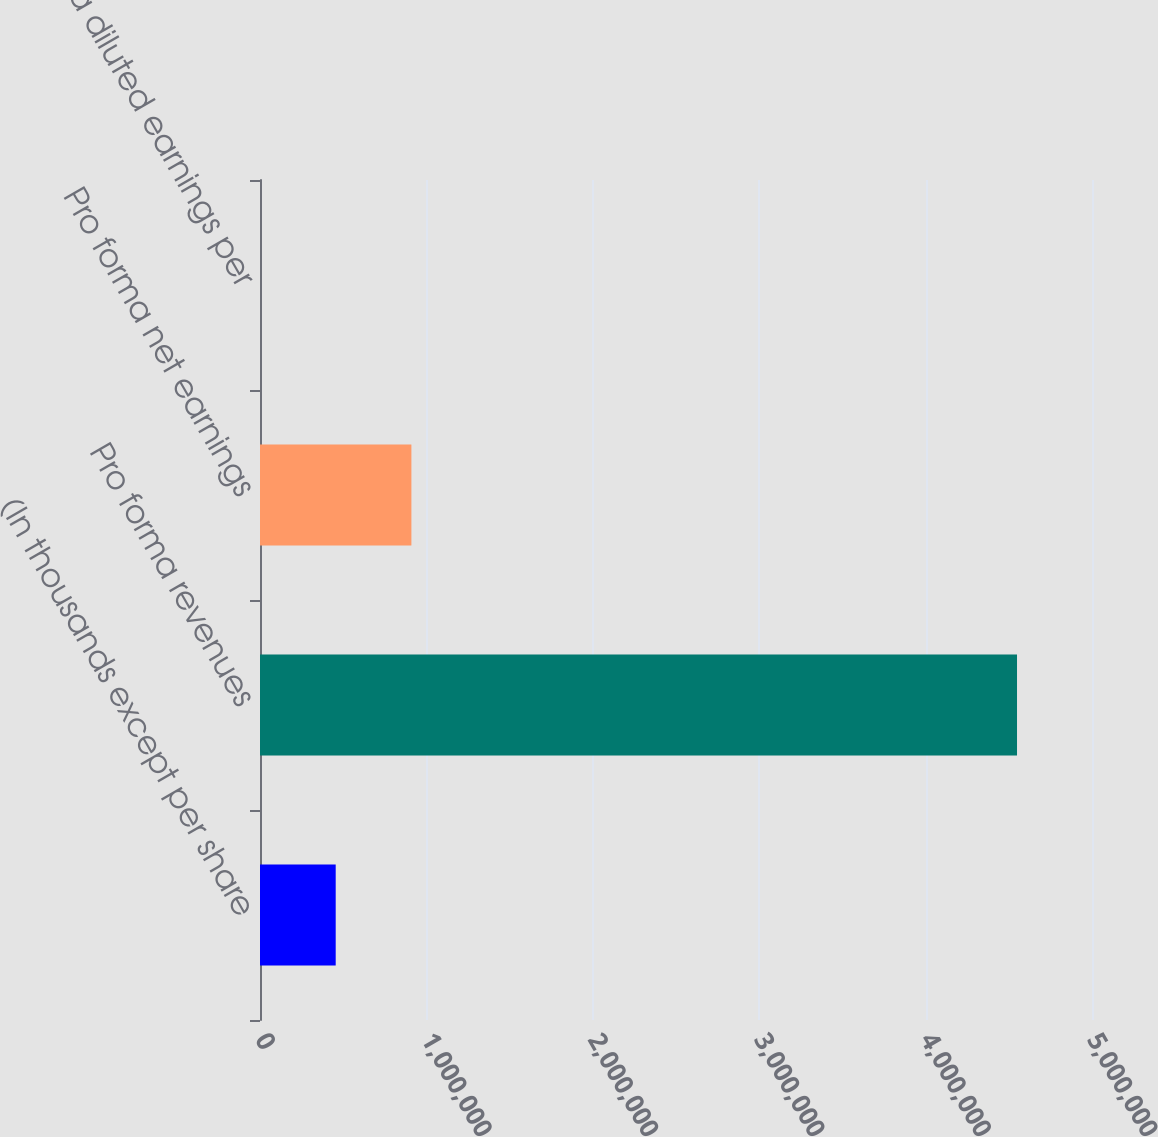Convert chart to OTSL. <chart><loc_0><loc_0><loc_500><loc_500><bar_chart><fcel>(In thousands except per share<fcel>Pro forma revenues<fcel>Pro forma net earnings<fcel>Pro forma diluted earnings per<nl><fcel>454940<fcel>4.54939e+06<fcel>909878<fcel>1.32<nl></chart> 